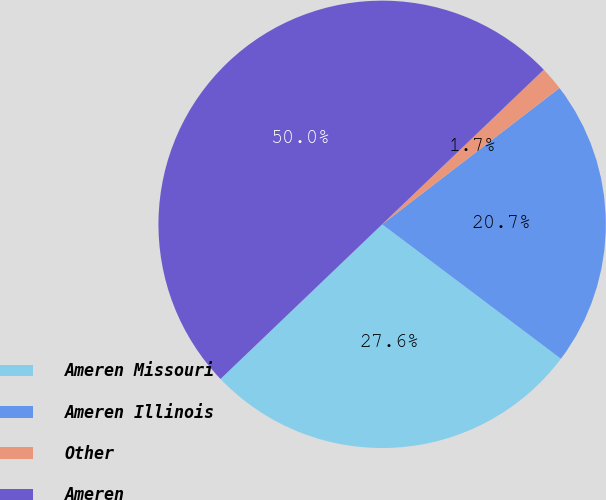Convert chart to OTSL. <chart><loc_0><loc_0><loc_500><loc_500><pie_chart><fcel>Ameren Missouri<fcel>Ameren Illinois<fcel>Other<fcel>Ameren<nl><fcel>27.59%<fcel>20.69%<fcel>1.72%<fcel>50.0%<nl></chart> 